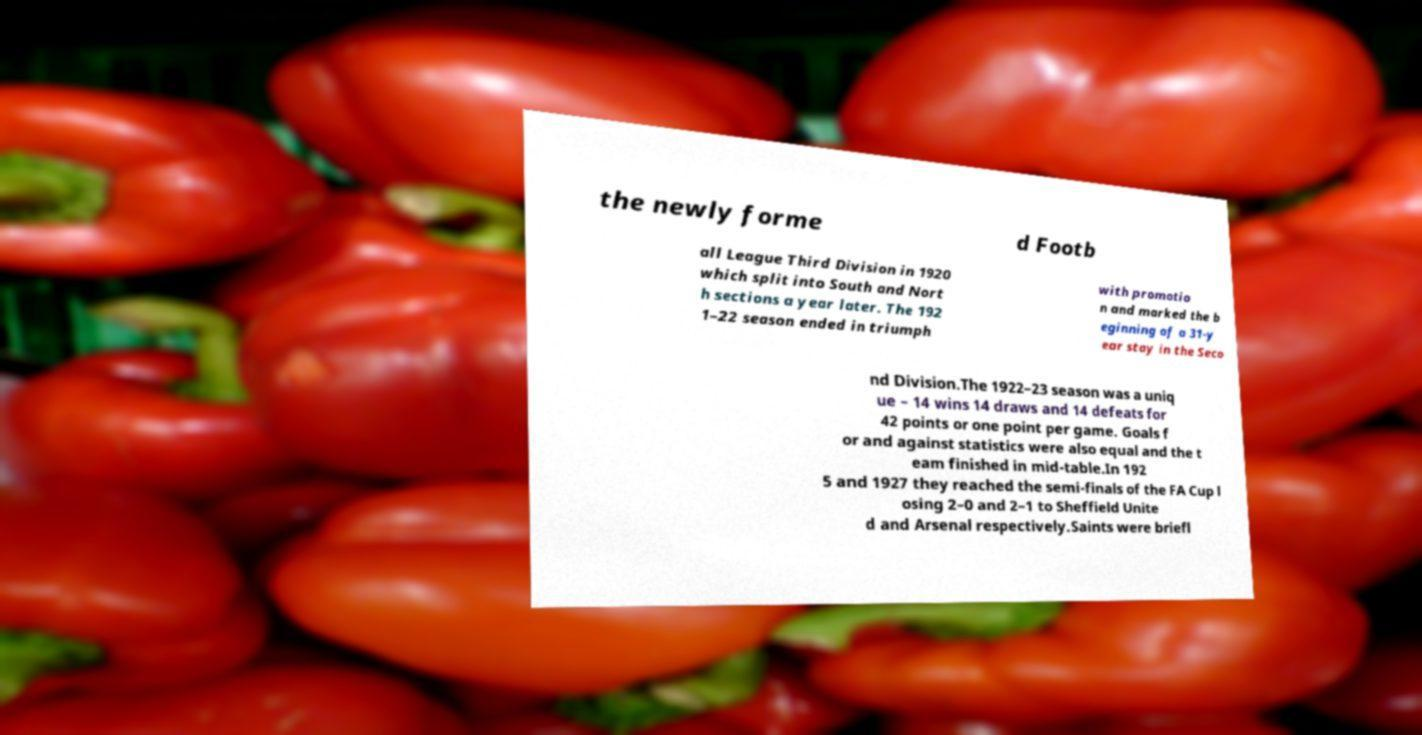For documentation purposes, I need the text within this image transcribed. Could you provide that? the newly forme d Footb all League Third Division in 1920 which split into South and Nort h sections a year later. The 192 1–22 season ended in triumph with promotio n and marked the b eginning of a 31-y ear stay in the Seco nd Division.The 1922–23 season was a uniq ue – 14 wins 14 draws and 14 defeats for 42 points or one point per game. Goals f or and against statistics were also equal and the t eam finished in mid-table.In 192 5 and 1927 they reached the semi-finals of the FA Cup l osing 2–0 and 2–1 to Sheffield Unite d and Arsenal respectively.Saints were briefl 